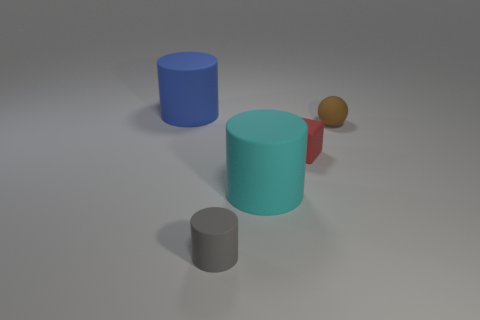How many tiny red rubber cubes are there?
Provide a succinct answer. 1. What is the shape of the matte object that is both to the left of the cyan cylinder and in front of the big blue cylinder?
Keep it short and to the point. Cylinder. Is there a tiny green cylinder that has the same material as the small ball?
Your answer should be very brief. No. Is the number of large cyan things that are to the left of the cyan thing the same as the number of tiny red matte objects that are left of the tiny brown sphere?
Keep it short and to the point. No. There is a cylinder that is behind the rubber ball; what is its size?
Your response must be concise. Large. There is a matte cylinder in front of the big rubber thing right of the gray thing; how many big matte cylinders are on the left side of it?
Ensure brevity in your answer.  1. Are the block that is right of the blue matte thing and the big cylinder on the right side of the tiny gray cylinder made of the same material?
Your answer should be compact. Yes. How many blue objects have the same shape as the gray thing?
Ensure brevity in your answer.  1. Are there more gray objects to the left of the small red rubber thing than tiny green shiny objects?
Make the answer very short. Yes. There is a large matte object on the right side of the matte object behind the small brown object in front of the big blue cylinder; what shape is it?
Offer a terse response. Cylinder. 